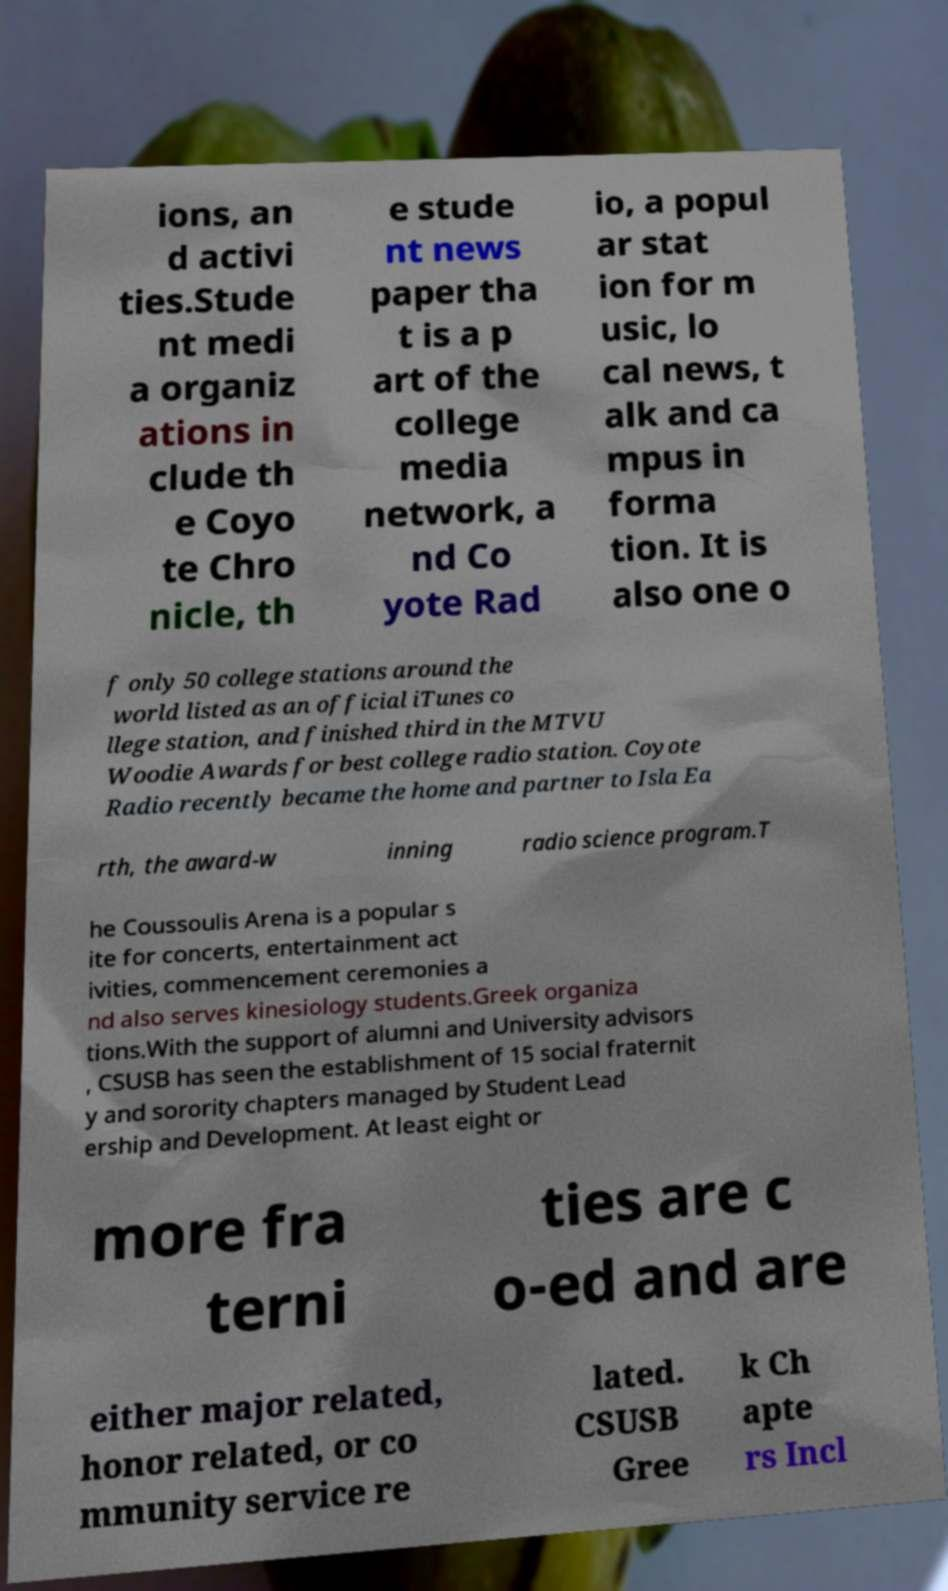Could you assist in decoding the text presented in this image and type it out clearly? ions, an d activi ties.Stude nt medi a organiz ations in clude th e Coyo te Chro nicle, th e stude nt news paper tha t is a p art of the college media network, a nd Co yote Rad io, a popul ar stat ion for m usic, lo cal news, t alk and ca mpus in forma tion. It is also one o f only 50 college stations around the world listed as an official iTunes co llege station, and finished third in the MTVU Woodie Awards for best college radio station. Coyote Radio recently became the home and partner to Isla Ea rth, the award-w inning radio science program.T he Coussoulis Arena is a popular s ite for concerts, entertainment act ivities, commencement ceremonies a nd also serves kinesiology students.Greek organiza tions.With the support of alumni and University advisors , CSUSB has seen the establishment of 15 social fraternit y and sorority chapters managed by Student Lead ership and Development. At least eight or more fra terni ties are c o-ed and are either major related, honor related, or co mmunity service re lated. CSUSB Gree k Ch apte rs Incl 